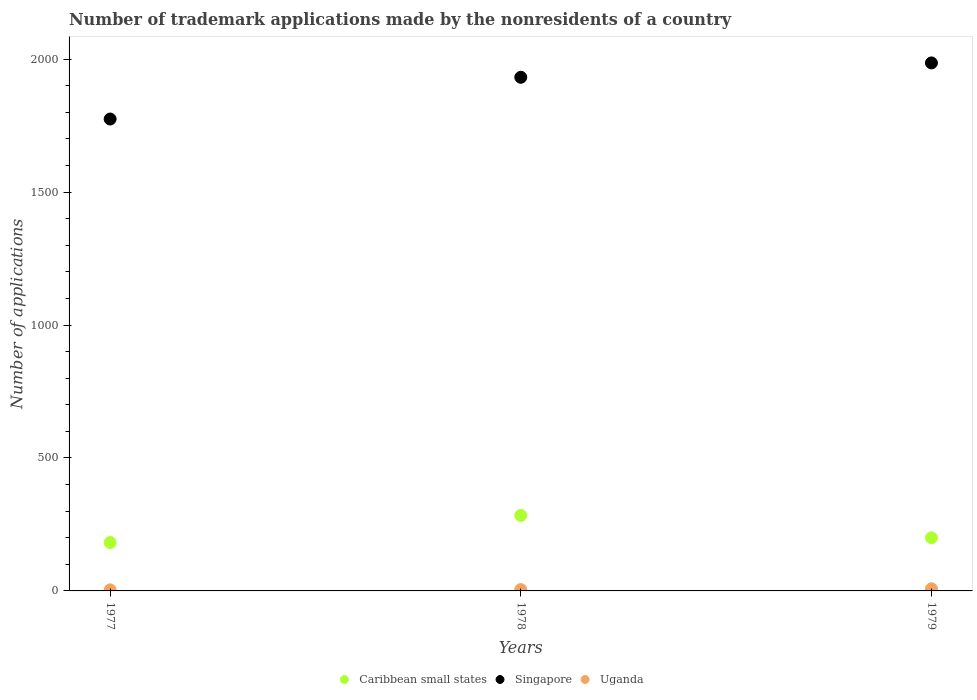What is the number of trademark applications made by the nonresidents in Caribbean small states in 1978?
Provide a short and direct response. 284. Across all years, what is the maximum number of trademark applications made by the nonresidents in Singapore?
Give a very brief answer. 1986. Across all years, what is the minimum number of trademark applications made by the nonresidents in Singapore?
Provide a succinct answer. 1775. In which year was the number of trademark applications made by the nonresidents in Caribbean small states maximum?
Ensure brevity in your answer.  1978. What is the difference between the number of trademark applications made by the nonresidents in Singapore in 1978 and the number of trademark applications made by the nonresidents in Uganda in 1977?
Give a very brief answer. 1928. What is the average number of trademark applications made by the nonresidents in Uganda per year?
Provide a succinct answer. 5.67. In the year 1979, what is the difference between the number of trademark applications made by the nonresidents in Singapore and number of trademark applications made by the nonresidents in Caribbean small states?
Ensure brevity in your answer.  1786. What is the ratio of the number of trademark applications made by the nonresidents in Uganda in 1977 to that in 1979?
Your answer should be compact. 0.5. What is the difference between the highest and the second highest number of trademark applications made by the nonresidents in Caribbean small states?
Your response must be concise. 84. What is the difference between the highest and the lowest number of trademark applications made by the nonresidents in Caribbean small states?
Offer a very short reply. 102. In how many years, is the number of trademark applications made by the nonresidents in Uganda greater than the average number of trademark applications made by the nonresidents in Uganda taken over all years?
Offer a very short reply. 1. Is the sum of the number of trademark applications made by the nonresidents in Singapore in 1977 and 1978 greater than the maximum number of trademark applications made by the nonresidents in Uganda across all years?
Offer a terse response. Yes. Is it the case that in every year, the sum of the number of trademark applications made by the nonresidents in Uganda and number of trademark applications made by the nonresidents in Singapore  is greater than the number of trademark applications made by the nonresidents in Caribbean small states?
Your response must be concise. Yes. Does the number of trademark applications made by the nonresidents in Uganda monotonically increase over the years?
Offer a terse response. Yes. Is the number of trademark applications made by the nonresidents in Uganda strictly greater than the number of trademark applications made by the nonresidents in Singapore over the years?
Ensure brevity in your answer.  No. How many years are there in the graph?
Make the answer very short. 3. What is the difference between two consecutive major ticks on the Y-axis?
Make the answer very short. 500. Are the values on the major ticks of Y-axis written in scientific E-notation?
Give a very brief answer. No. Does the graph contain any zero values?
Provide a short and direct response. No. Does the graph contain grids?
Your response must be concise. No. Where does the legend appear in the graph?
Your response must be concise. Bottom center. How are the legend labels stacked?
Your response must be concise. Horizontal. What is the title of the graph?
Your answer should be very brief. Number of trademark applications made by the nonresidents of a country. Does "West Bank and Gaza" appear as one of the legend labels in the graph?
Make the answer very short. No. What is the label or title of the Y-axis?
Ensure brevity in your answer.  Number of applications. What is the Number of applications in Caribbean small states in 1977?
Ensure brevity in your answer.  182. What is the Number of applications in Singapore in 1977?
Your response must be concise. 1775. What is the Number of applications of Caribbean small states in 1978?
Offer a very short reply. 284. What is the Number of applications in Singapore in 1978?
Make the answer very short. 1932. What is the Number of applications of Uganda in 1978?
Your response must be concise. 5. What is the Number of applications in Caribbean small states in 1979?
Provide a short and direct response. 200. What is the Number of applications of Singapore in 1979?
Your response must be concise. 1986. What is the Number of applications in Uganda in 1979?
Give a very brief answer. 8. Across all years, what is the maximum Number of applications of Caribbean small states?
Offer a terse response. 284. Across all years, what is the maximum Number of applications in Singapore?
Give a very brief answer. 1986. Across all years, what is the minimum Number of applications in Caribbean small states?
Make the answer very short. 182. Across all years, what is the minimum Number of applications of Singapore?
Provide a succinct answer. 1775. Across all years, what is the minimum Number of applications in Uganda?
Your answer should be very brief. 4. What is the total Number of applications in Caribbean small states in the graph?
Ensure brevity in your answer.  666. What is the total Number of applications in Singapore in the graph?
Offer a terse response. 5693. What is the total Number of applications of Uganda in the graph?
Offer a very short reply. 17. What is the difference between the Number of applications of Caribbean small states in 1977 and that in 1978?
Give a very brief answer. -102. What is the difference between the Number of applications in Singapore in 1977 and that in 1978?
Your answer should be compact. -157. What is the difference between the Number of applications of Singapore in 1977 and that in 1979?
Offer a very short reply. -211. What is the difference between the Number of applications of Caribbean small states in 1978 and that in 1979?
Give a very brief answer. 84. What is the difference between the Number of applications of Singapore in 1978 and that in 1979?
Offer a very short reply. -54. What is the difference between the Number of applications in Uganda in 1978 and that in 1979?
Your answer should be very brief. -3. What is the difference between the Number of applications in Caribbean small states in 1977 and the Number of applications in Singapore in 1978?
Offer a terse response. -1750. What is the difference between the Number of applications in Caribbean small states in 1977 and the Number of applications in Uganda in 1978?
Provide a succinct answer. 177. What is the difference between the Number of applications of Singapore in 1977 and the Number of applications of Uganda in 1978?
Ensure brevity in your answer.  1770. What is the difference between the Number of applications of Caribbean small states in 1977 and the Number of applications of Singapore in 1979?
Make the answer very short. -1804. What is the difference between the Number of applications in Caribbean small states in 1977 and the Number of applications in Uganda in 1979?
Offer a terse response. 174. What is the difference between the Number of applications of Singapore in 1977 and the Number of applications of Uganda in 1979?
Keep it short and to the point. 1767. What is the difference between the Number of applications of Caribbean small states in 1978 and the Number of applications of Singapore in 1979?
Make the answer very short. -1702. What is the difference between the Number of applications of Caribbean small states in 1978 and the Number of applications of Uganda in 1979?
Offer a terse response. 276. What is the difference between the Number of applications of Singapore in 1978 and the Number of applications of Uganda in 1979?
Offer a terse response. 1924. What is the average Number of applications of Caribbean small states per year?
Keep it short and to the point. 222. What is the average Number of applications of Singapore per year?
Your response must be concise. 1897.67. What is the average Number of applications in Uganda per year?
Provide a succinct answer. 5.67. In the year 1977, what is the difference between the Number of applications in Caribbean small states and Number of applications in Singapore?
Provide a succinct answer. -1593. In the year 1977, what is the difference between the Number of applications of Caribbean small states and Number of applications of Uganda?
Ensure brevity in your answer.  178. In the year 1977, what is the difference between the Number of applications of Singapore and Number of applications of Uganda?
Your answer should be compact. 1771. In the year 1978, what is the difference between the Number of applications in Caribbean small states and Number of applications in Singapore?
Your answer should be compact. -1648. In the year 1978, what is the difference between the Number of applications of Caribbean small states and Number of applications of Uganda?
Offer a terse response. 279. In the year 1978, what is the difference between the Number of applications in Singapore and Number of applications in Uganda?
Provide a succinct answer. 1927. In the year 1979, what is the difference between the Number of applications of Caribbean small states and Number of applications of Singapore?
Keep it short and to the point. -1786. In the year 1979, what is the difference between the Number of applications of Caribbean small states and Number of applications of Uganda?
Offer a very short reply. 192. In the year 1979, what is the difference between the Number of applications in Singapore and Number of applications in Uganda?
Keep it short and to the point. 1978. What is the ratio of the Number of applications in Caribbean small states in 1977 to that in 1978?
Ensure brevity in your answer.  0.64. What is the ratio of the Number of applications of Singapore in 1977 to that in 1978?
Offer a very short reply. 0.92. What is the ratio of the Number of applications in Uganda in 1977 to that in 1978?
Keep it short and to the point. 0.8. What is the ratio of the Number of applications of Caribbean small states in 1977 to that in 1979?
Your answer should be compact. 0.91. What is the ratio of the Number of applications in Singapore in 1977 to that in 1979?
Ensure brevity in your answer.  0.89. What is the ratio of the Number of applications of Caribbean small states in 1978 to that in 1979?
Your answer should be compact. 1.42. What is the ratio of the Number of applications of Singapore in 1978 to that in 1979?
Your response must be concise. 0.97. What is the difference between the highest and the second highest Number of applications in Caribbean small states?
Give a very brief answer. 84. What is the difference between the highest and the second highest Number of applications in Singapore?
Offer a very short reply. 54. What is the difference between the highest and the second highest Number of applications of Uganda?
Your answer should be compact. 3. What is the difference between the highest and the lowest Number of applications in Caribbean small states?
Keep it short and to the point. 102. What is the difference between the highest and the lowest Number of applications of Singapore?
Offer a terse response. 211. 